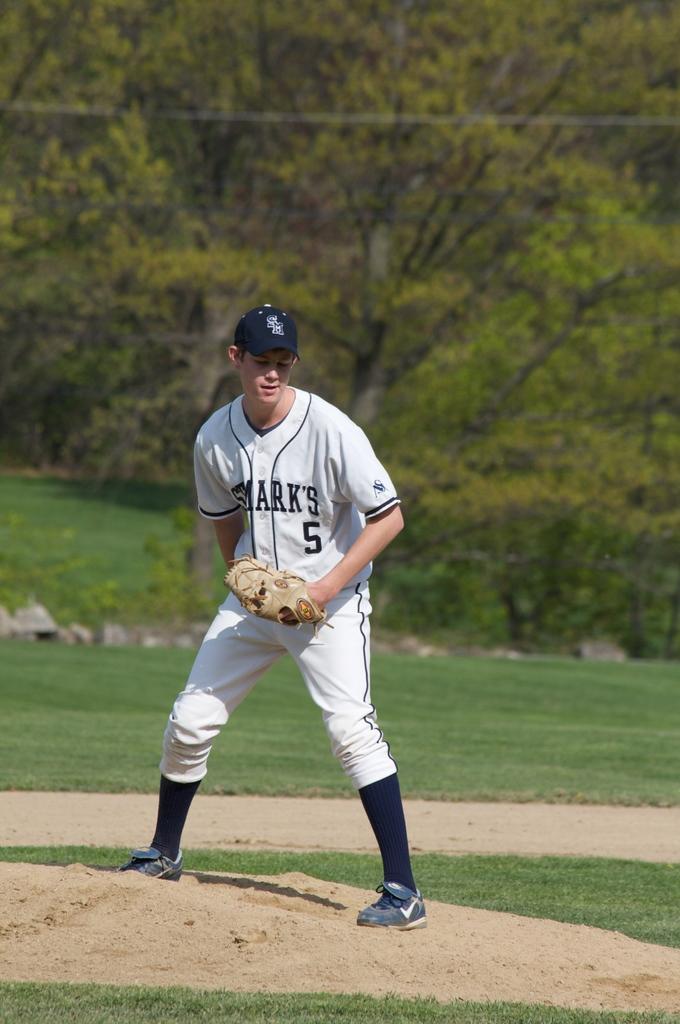What baseball team does the boy play for?
Provide a succinct answer. Sharks. 